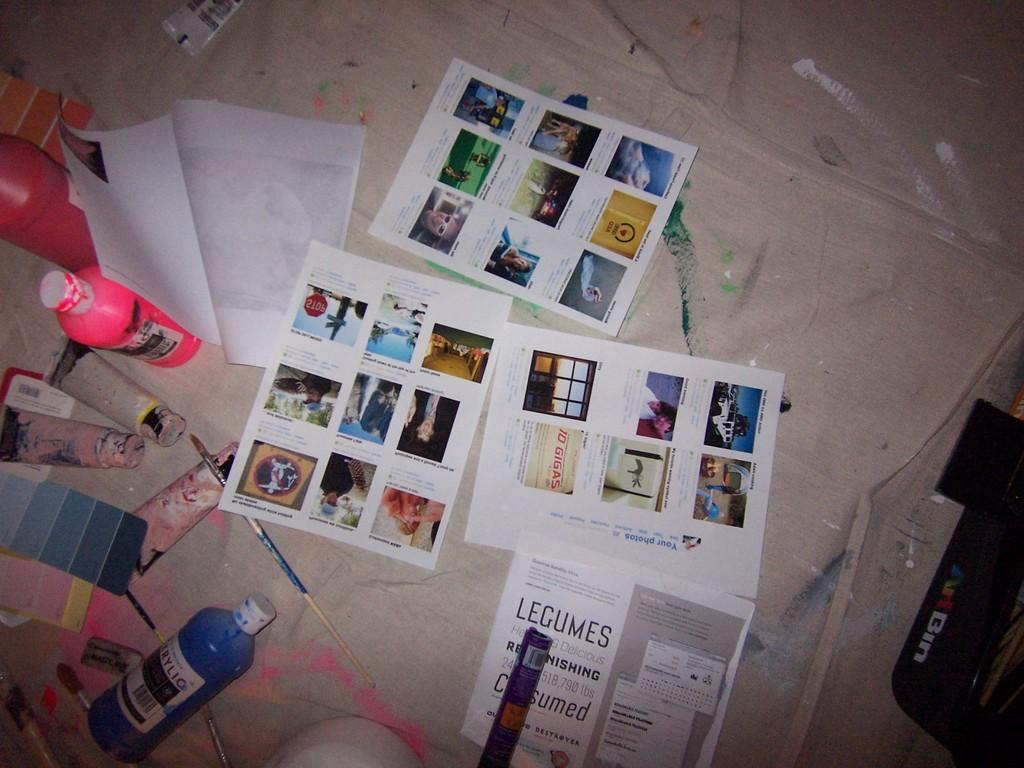What objects are on the table in the image? There are papers on the table in the image. What items are related to painting in the image? There are paint boxes, paint bottles, and paint brushes in the image. What type of steel is used to make the paint brushes in the image? There is no information about the type of steel used in the paint brushes, as the focus is on the presence of paint brushes and not their composition. 